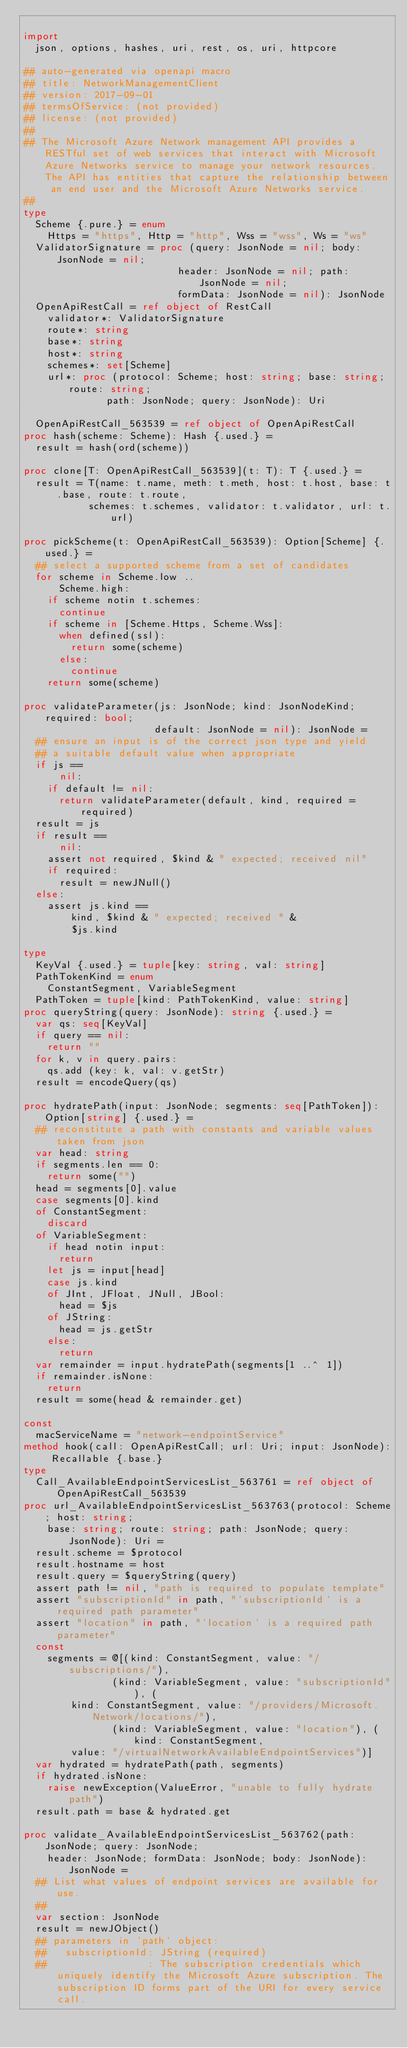Convert code to text. <code><loc_0><loc_0><loc_500><loc_500><_Nim_>
import
  json, options, hashes, uri, rest, os, uri, httpcore

## auto-generated via openapi macro
## title: NetworkManagementClient
## version: 2017-09-01
## termsOfService: (not provided)
## license: (not provided)
## 
## The Microsoft Azure Network management API provides a RESTful set of web services that interact with Microsoft Azure Networks service to manage your network resources. The API has entities that capture the relationship between an end user and the Microsoft Azure Networks service.
## 
type
  Scheme {.pure.} = enum
    Https = "https", Http = "http", Wss = "wss", Ws = "ws"
  ValidatorSignature = proc (query: JsonNode = nil; body: JsonNode = nil;
                          header: JsonNode = nil; path: JsonNode = nil;
                          formData: JsonNode = nil): JsonNode
  OpenApiRestCall = ref object of RestCall
    validator*: ValidatorSignature
    route*: string
    base*: string
    host*: string
    schemes*: set[Scheme]
    url*: proc (protocol: Scheme; host: string; base: string; route: string;
              path: JsonNode; query: JsonNode): Uri

  OpenApiRestCall_563539 = ref object of OpenApiRestCall
proc hash(scheme: Scheme): Hash {.used.} =
  result = hash(ord(scheme))

proc clone[T: OpenApiRestCall_563539](t: T): T {.used.} =
  result = T(name: t.name, meth: t.meth, host: t.host, base: t.base, route: t.route,
           schemes: t.schemes, validator: t.validator, url: t.url)

proc pickScheme(t: OpenApiRestCall_563539): Option[Scheme] {.used.} =
  ## select a supported scheme from a set of candidates
  for scheme in Scheme.low ..
      Scheme.high:
    if scheme notin t.schemes:
      continue
    if scheme in [Scheme.Https, Scheme.Wss]:
      when defined(ssl):
        return some(scheme)
      else:
        continue
    return some(scheme)

proc validateParameter(js: JsonNode; kind: JsonNodeKind; required: bool;
                      default: JsonNode = nil): JsonNode =
  ## ensure an input is of the correct json type and yield
  ## a suitable default value when appropriate
  if js ==
      nil:
    if default != nil:
      return validateParameter(default, kind, required = required)
  result = js
  if result ==
      nil:
    assert not required, $kind & " expected; received nil"
    if required:
      result = newJNull()
  else:
    assert js.kind ==
        kind, $kind & " expected; received " &
        $js.kind

type
  KeyVal {.used.} = tuple[key: string, val: string]
  PathTokenKind = enum
    ConstantSegment, VariableSegment
  PathToken = tuple[kind: PathTokenKind, value: string]
proc queryString(query: JsonNode): string {.used.} =
  var qs: seq[KeyVal]
  if query == nil:
    return ""
  for k, v in query.pairs:
    qs.add (key: k, val: v.getStr)
  result = encodeQuery(qs)

proc hydratePath(input: JsonNode; segments: seq[PathToken]): Option[string] {.used.} =
  ## reconstitute a path with constants and variable values taken from json
  var head: string
  if segments.len == 0:
    return some("")
  head = segments[0].value
  case segments[0].kind
  of ConstantSegment:
    discard
  of VariableSegment:
    if head notin input:
      return
    let js = input[head]
    case js.kind
    of JInt, JFloat, JNull, JBool:
      head = $js
    of JString:
      head = js.getStr
    else:
      return
  var remainder = input.hydratePath(segments[1 ..^ 1])
  if remainder.isNone:
    return
  result = some(head & remainder.get)

const
  macServiceName = "network-endpointService"
method hook(call: OpenApiRestCall; url: Uri; input: JsonNode): Recallable {.base.}
type
  Call_AvailableEndpointServicesList_563761 = ref object of OpenApiRestCall_563539
proc url_AvailableEndpointServicesList_563763(protocol: Scheme; host: string;
    base: string; route: string; path: JsonNode; query: JsonNode): Uri =
  result.scheme = $protocol
  result.hostname = host
  result.query = $queryString(query)
  assert path != nil, "path is required to populate template"
  assert "subscriptionId" in path, "`subscriptionId` is a required path parameter"
  assert "location" in path, "`location` is a required path parameter"
  const
    segments = @[(kind: ConstantSegment, value: "/subscriptions/"),
               (kind: VariableSegment, value: "subscriptionId"), (
        kind: ConstantSegment, value: "/providers/Microsoft.Network/locations/"),
               (kind: VariableSegment, value: "location"), (kind: ConstantSegment,
        value: "/virtualNetworkAvailableEndpointServices")]
  var hydrated = hydratePath(path, segments)
  if hydrated.isNone:
    raise newException(ValueError, "unable to fully hydrate path")
  result.path = base & hydrated.get

proc validate_AvailableEndpointServicesList_563762(path: JsonNode; query: JsonNode;
    header: JsonNode; formData: JsonNode; body: JsonNode): JsonNode =
  ## List what values of endpoint services are available for use.
  ## 
  var section: JsonNode
  result = newJObject()
  ## parameters in `path` object:
  ##   subscriptionId: JString (required)
  ##                 : The subscription credentials which uniquely identify the Microsoft Azure subscription. The subscription ID forms part of the URI for every service call.</code> 